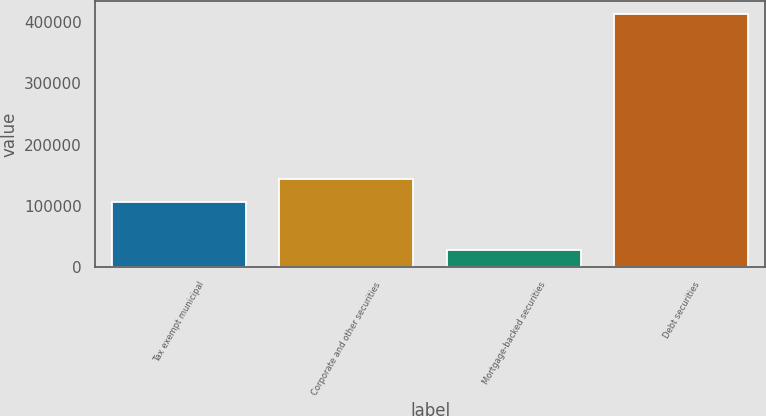Convert chart. <chart><loc_0><loc_0><loc_500><loc_500><bar_chart><fcel>Tax exempt municipal<fcel>Corporate and other securities<fcel>Mortgage-backed securities<fcel>Debt securities<nl><fcel>105403<fcel>143983<fcel>27496<fcel>413293<nl></chart> 